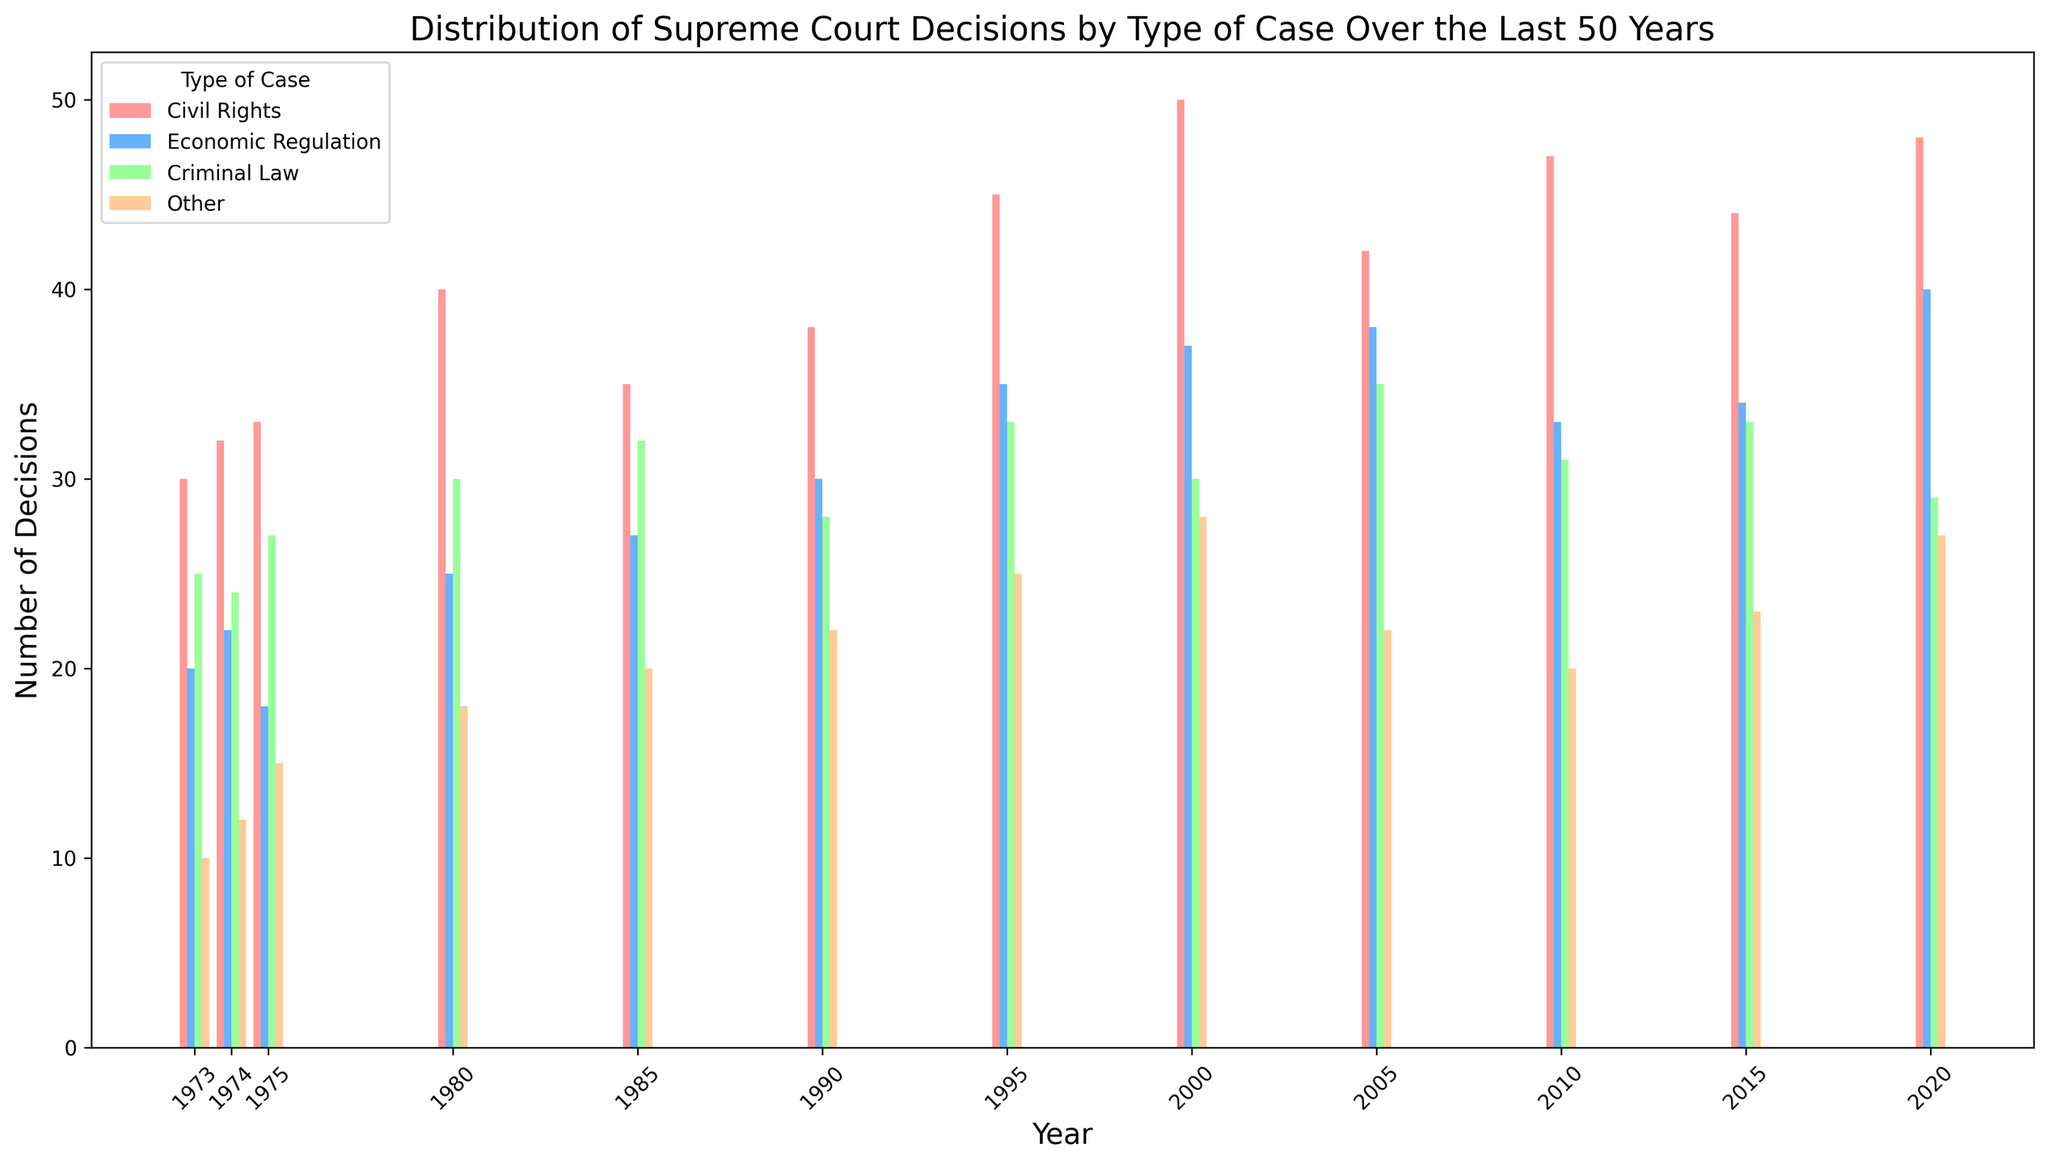what's the most common type of case decided by the Supreme Court over the last 50 years? By visually inspecting the height of bars for each type of case across years, we can see that "Civil Rights" consistently has the tallest bars.
Answer: Civil Rights which year had the highest number of Supreme Court decisions regarding economic regulation cases? The highest bar in the Economic Regulation series is in 2020.
Answer: 2020 what's the total number of Supreme Court decisions made in 2000 across all types of cases? Sum the heights of all bars in the year 2000: 50 (Civil Rights) + 37 (Economic Regulation) + 30 (Criminal Law) + 28 (Other) = 145.
Answer: 145 is there a year when criminal law decisions were greater than both economic regulation and other types of cases? In 2005, the bar for Criminal Law (35) is taller than both Economic Regulation (38) and Other (22).
Answer: 2005 by how much did the number of civil rights decisions change between 1980 and 2020? Subtract the Civil Rights decisions in 1980 from those in 2020: 48 - 40 = 8.
Answer: 8 which type of case shows the most significant fluctuation in the number of decisions over time? Visually, the "Civil Rights" cases have the most significant changes in bar heights, indicating fluctuation.
Answer: Civil Rights in which year did other types of cases get the least number of decisions, and what was that number? Visually, the shortest bar for "Other" is in 1973 with a height of 10.
Answer: 1973, 10 compare the number of civil rights decisions in 1975 and 1995. How do they differ? Subtract the number of decisions in 1975 from those in 1995: 45 - 33 = 12.
Answer: 12 what's the average number of economic regulation decisions made across all recorded years? Add all Economic Regulation decisions and divide by the number of years: (20+22+18+25+27+30+35+37+38+33+34+40) / 12 = 299 / 12 = 24.92, approximately 25.
Answer: 25 